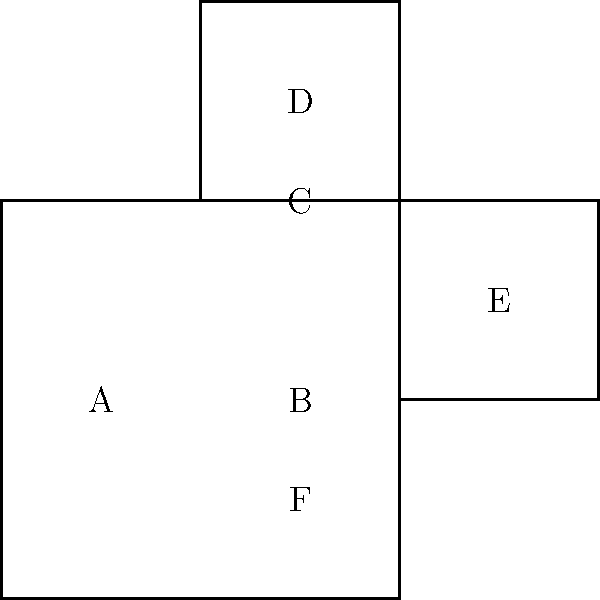Given the unfolded cube pattern shown in the image, if you fold it into a 3D cube, which face will be opposite to face A? To solve this problem, let's follow these steps:

1. Visualize the folding process:
   - Face B will form the bottom of the cube.
   - Faces A, C, and D will fold up to form three sides of the cube.
   - Face E will fold to the right to form another side.
   - Face F will fold up to form the top of the cube.

2. Identify the relationships between faces:
   - A is connected to B, C, and F.
   - D is connected to C.
   - E is connected to B and F.

3. Determine the opposite face:
   - In a cube, opposite faces are those that don't share any edges.
   - Face A shares edges with B, C, and F.
   - The only face not connected to A either directly or through an adjacent face is D.

4. Confirm the answer:
   - If we imagine the cube fully formed, we can see that D would indeed be on the opposite side of A.

Therefore, the face opposite to A in the folded cube will be D.
Answer: D 